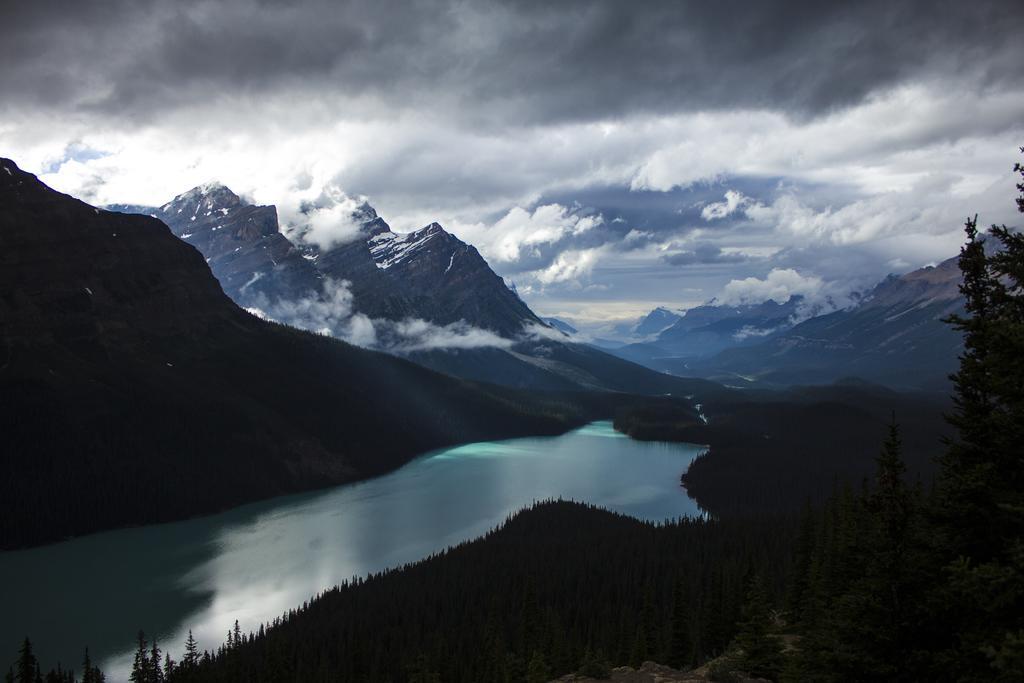How would you summarize this image in a sentence or two? In this picture we can see a few plants and trees on the right side. There is the water. We can see a few mountains covered with the snow in the background. Sky is cloudy. 